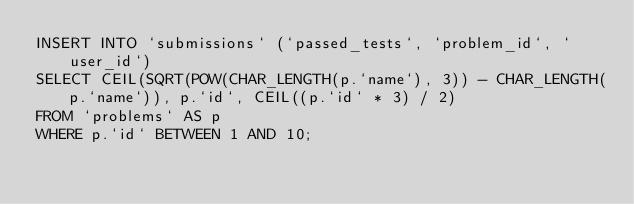<code> <loc_0><loc_0><loc_500><loc_500><_SQL_>INSERT INTO `submissions` (`passed_tests`, `problem_id`, `user_id`)
SELECT CEIL(SQRT(POW(CHAR_LENGTH(p.`name`), 3)) - CHAR_LENGTH(p.`name`)), p.`id`, CEIL((p.`id` * 3) / 2)
FROM `problems` AS p
WHERE p.`id` BETWEEN 1 AND 10;</code> 